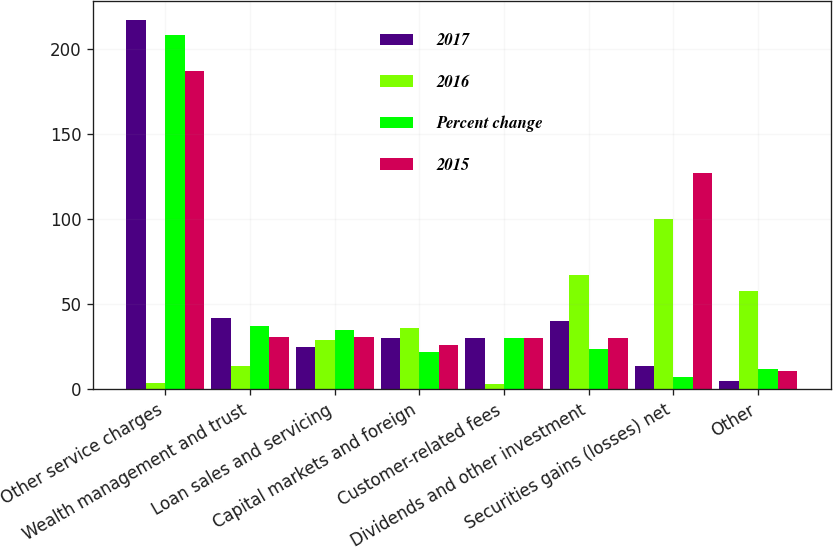<chart> <loc_0><loc_0><loc_500><loc_500><stacked_bar_chart><ecel><fcel>Other service charges<fcel>Wealth management and trust<fcel>Loan sales and servicing<fcel>Capital markets and foreign<fcel>Customer-related fees<fcel>Dividends and other investment<fcel>Securities gains (losses) net<fcel>Other<nl><fcel>2017<fcel>217<fcel>42<fcel>25<fcel>30<fcel>30<fcel>40<fcel>14<fcel>5<nl><fcel>2016<fcel>4<fcel>14<fcel>29<fcel>36<fcel>3<fcel>67<fcel>100<fcel>58<nl><fcel>Percent change<fcel>208<fcel>37<fcel>35<fcel>22<fcel>30<fcel>24<fcel>7<fcel>12<nl><fcel>2015<fcel>187<fcel>31<fcel>31<fcel>26<fcel>30<fcel>30<fcel>127<fcel>11<nl></chart> 